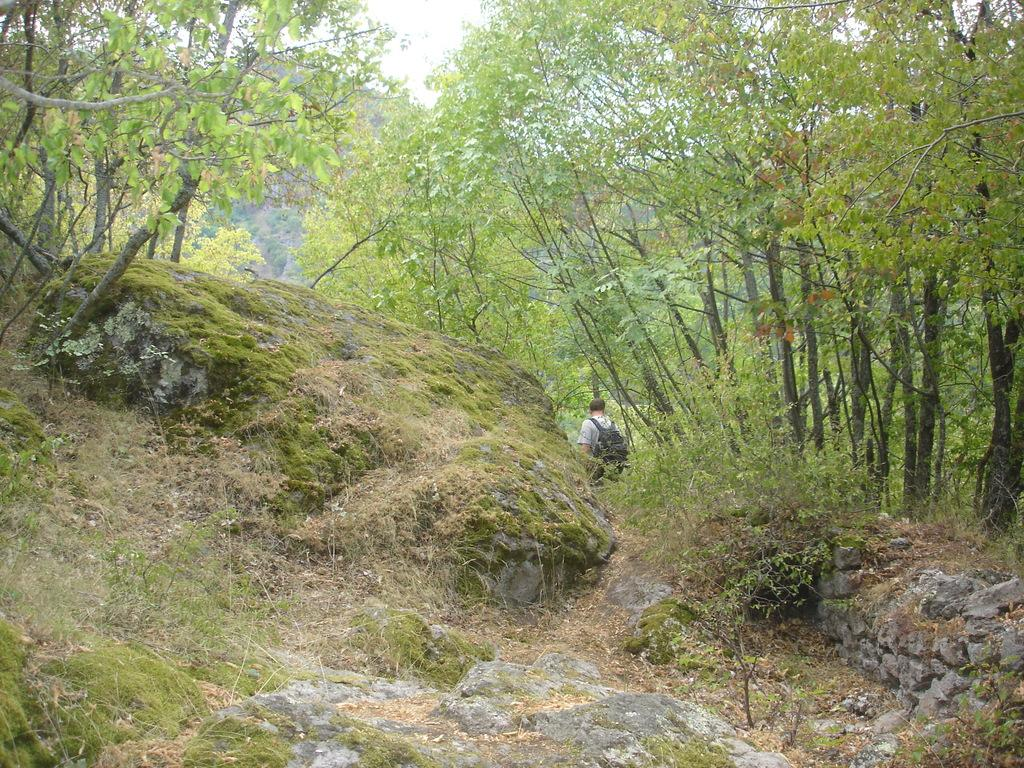What is the main subject of the image? There is a person walking in the image. What type of surface is the person walking on? The person is walking on grass. What can be seen in the background of the image? There are trees in the background of the image. What type of sack is being carried by the person in the image? There is no sack visible in the image; the person is simply walking on grass with trees in the background. 